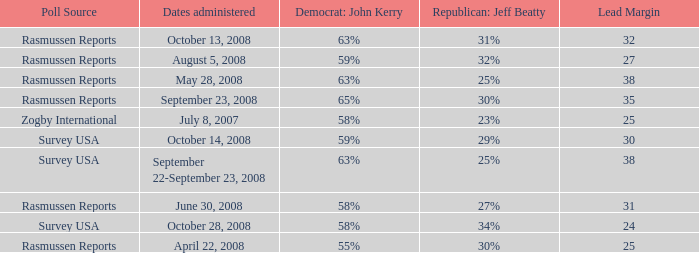What percent is the lead margin of 25 that Republican: Jeff Beatty has according to poll source Rasmussen Reports? 30%. 